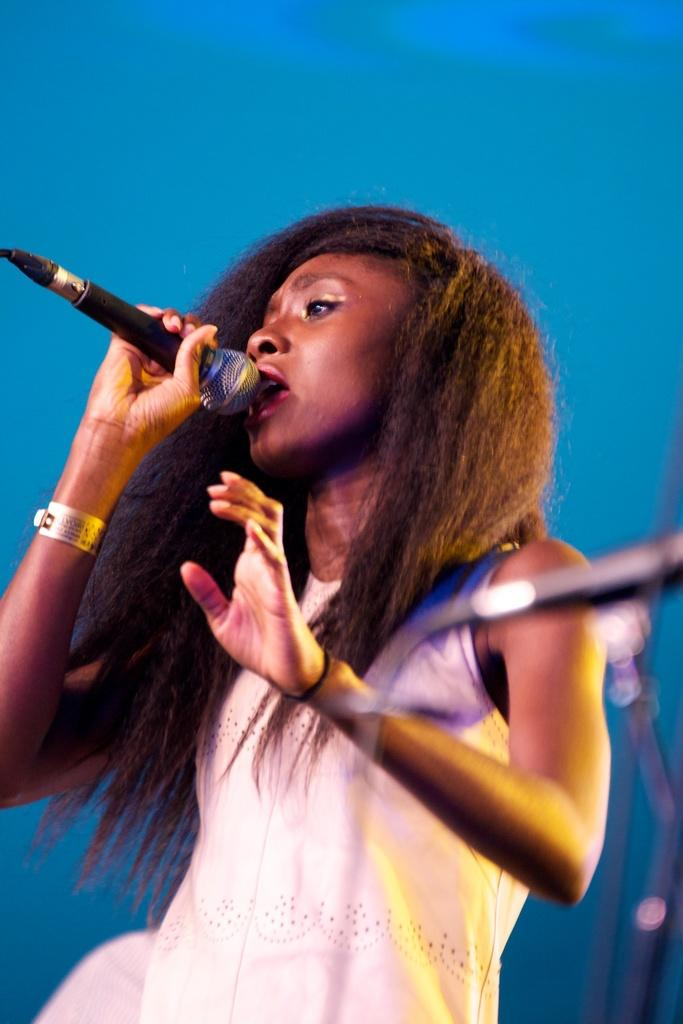What is: What is the woman in the image doing? The woman is singing a song. What is the woman holding while singing? The woman is holding a microphone. Can you describe the woman's hair in the image? The woman has straight hair. What color is the wall in the background of the image? There is a blue wall in the background of the image. Can you see any cherries on the woman's hair in the image? There are no cherries present in the image, and they are not mentioned in the provided facts. 